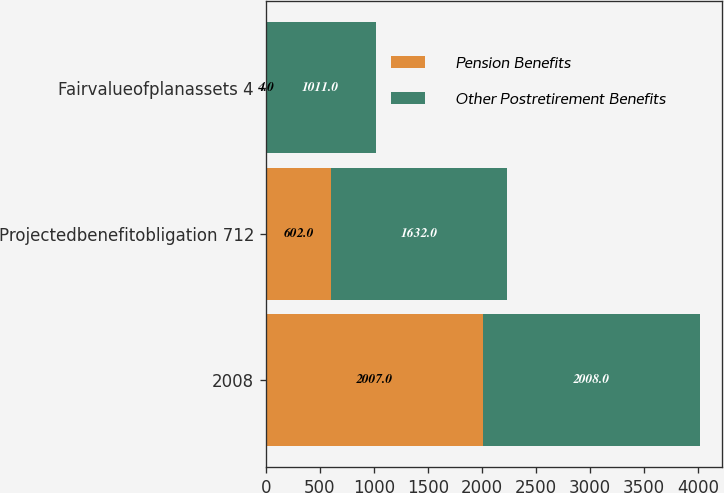Convert chart. <chart><loc_0><loc_0><loc_500><loc_500><stacked_bar_chart><ecel><fcel>2008<fcel>Projectedbenefitobligation 712<fcel>Fairvalueofplanassets 4<nl><fcel>Pension Benefits<fcel>2007<fcel>602<fcel>4<nl><fcel>Other Postretirement Benefits<fcel>2008<fcel>1632<fcel>1011<nl></chart> 